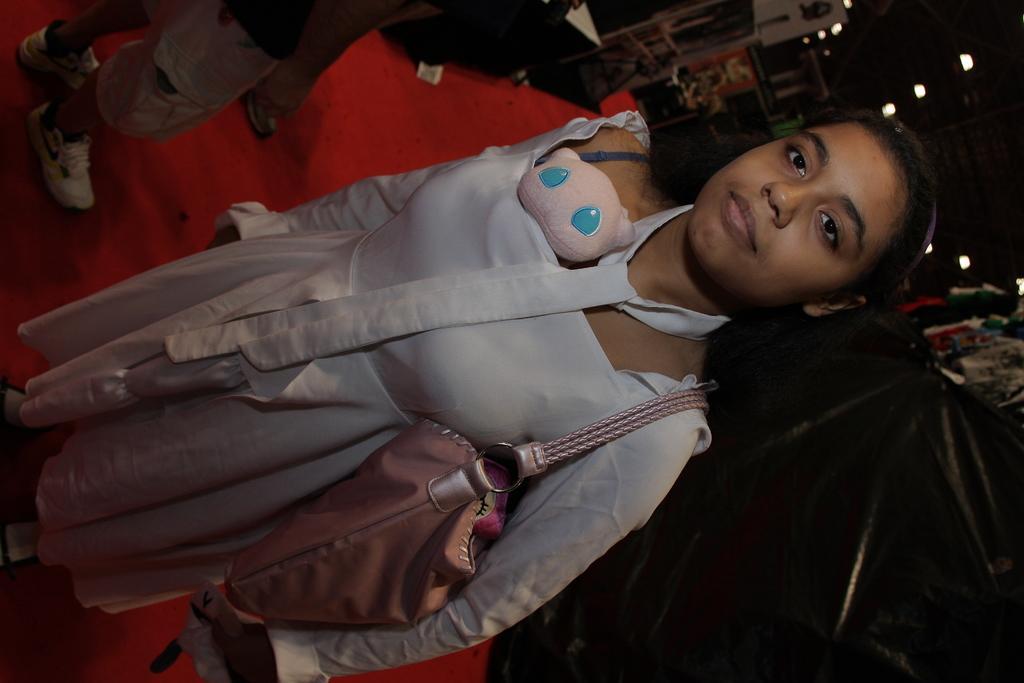Describe this image in one or two sentences. In this picture I can see a woman is standing and carrying a bag. In the background I can see lights, people and some other objects on the ground. 